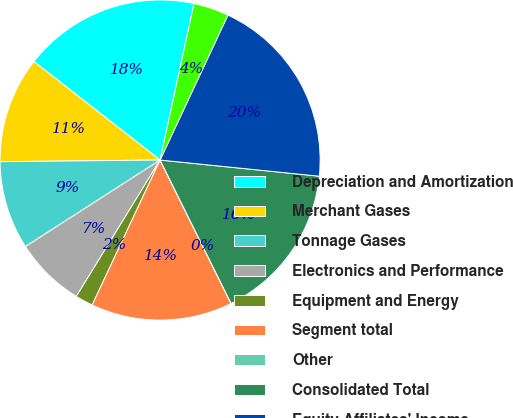<chart> <loc_0><loc_0><loc_500><loc_500><pie_chart><fcel>Depreciation and Amortization<fcel>Merchant Gases<fcel>Tonnage Gases<fcel>Electronics and Performance<fcel>Equipment and Energy<fcel>Segment total<fcel>Other<fcel>Consolidated Total<fcel>Equity Affiliates' Income<fcel>Other segments<nl><fcel>17.85%<fcel>10.71%<fcel>8.93%<fcel>7.14%<fcel>1.79%<fcel>14.28%<fcel>0.01%<fcel>16.07%<fcel>19.64%<fcel>3.57%<nl></chart> 